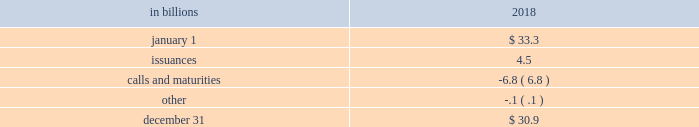The pnc financial services group , inc .
2013 form 10-k 65 liquidity and capital management liquidity risk has two fundamental components .
The first is potential loss assuming we were unable to meet our funding requirements at a reasonable cost .
The second is the potential inability to operate our businesses because adequate contingent liquidity is not available .
We manage liquidity risk at the consolidated company level ( bank , parent company and nonbank subsidiaries combined ) to help ensure that we can obtain cost-effective funding to meet current and future obligations under both normal 201cbusiness as usual 201d and stressful circumstances , and to help ensure that we maintain an appropriate level of contingent liquidity .
Management monitors liquidity through a series of early warning indicators that may indicate a potential market , or pnc-specific , liquidity stress event .
In addition , management performs a set of liquidity stress tests over multiple time horizons with varying levels of severity and maintains a contingency funding plan to address a potential liquidity stress event .
In the most severe liquidity stress simulation , we assume that our liquidity position is under pressure , while the market in general is under systemic pressure .
The simulation considers , among other things , the impact of restricted access to both secured and unsecured external sources of funding , accelerated run-off of customer deposits , valuation pressure on assets and heavy demand to fund committed obligations .
Parent company liquidity guidelines are designed to help ensure that sufficient liquidity is available to meet our parent company obligations over the succeeding 24-month period .
Liquidity-related risk limits are established within our enterprise liquidity management policy and supporting policies .
Management committees , including the asset and liability committee , and the board of directors and its risk committee regularly review compliance with key established limits .
In addition to these liquidity monitoring measures and tools described above , we also monitor our liquidity by reference to the liquidity coverage ratio ( lcr ) which is further described in the supervision and regulation section in item 1 of this report .
Pnc and pnc bank calculate the lcr on a daily basis and as of december 31 , 2018 , the lcr for pnc and pnc bank exceeded the fully phased-in requirement of 100% ( 100 % ) .
We provide additional information regarding regulatory liquidity requirements and their potential impact on us in the supervision and regulation section of item 1 business and item 1a risk factors of this report .
Sources of liquidity our largest source of liquidity on a consolidated basis is the customer deposit base generated by our banking businesses .
These deposits provide relatively stable and low-cost funding .
Total deposits increased to $ 267.8 billion at december 31 , 2018 from $ 265.1 billion at december 31 , 2017 driven by growth in interest-bearing deposits partially offset by a decrease in noninterest-bearing deposits .
See the funding sources section of the consolidated balance sheet review in this report for additional information related to our deposits .
Additionally , certain assets determined by us to be liquid as well as unused borrowing capacity from a number of sources are also available to manage our liquidity position .
At december 31 , 2018 , our liquid assets consisted of short-term investments ( federal funds sold , resale agreements , trading securities and interest-earning deposits with banks ) totaling $ 22.1 billion and securities available for sale totaling $ 63.4 billion .
The level of liquid assets fluctuates over time based on many factors , including market conditions , loan and deposit growth and balance sheet management activities .
Our liquid assets included $ 2.7 billion of securities available for sale and trading securities pledged as collateral to secure public and trust deposits , repurchase agreements and for other purposes .
In addition , $ 4.9 billion of securities held to maturity were also pledged as collateral for these purposes .
We also obtain liquidity through various forms of funding , including long-term debt ( senior notes , subordinated debt and fhlb borrowings ) and short-term borrowings ( securities sold under repurchase agreements , commercial paper and other short-term borrowings ) .
See note 10 borrowed funds and the funding sources section of the consolidated balance sheet review in this report for additional information related to our borrowings .
Total senior and subordinated debt , on a consolidated basis , decreased due to the following activity : table 24 : senior and subordinated debt .

At december 31 , 2018what was the liquid assets consisted made of short-term investments? 
Computations: (22.1 / (22.1 + 63.4))
Answer: 0.25848. The pnc financial services group , inc .
2013 form 10-k 65 liquidity and capital management liquidity risk has two fundamental components .
The first is potential loss assuming we were unable to meet our funding requirements at a reasonable cost .
The second is the potential inability to operate our businesses because adequate contingent liquidity is not available .
We manage liquidity risk at the consolidated company level ( bank , parent company and nonbank subsidiaries combined ) to help ensure that we can obtain cost-effective funding to meet current and future obligations under both normal 201cbusiness as usual 201d and stressful circumstances , and to help ensure that we maintain an appropriate level of contingent liquidity .
Management monitors liquidity through a series of early warning indicators that may indicate a potential market , or pnc-specific , liquidity stress event .
In addition , management performs a set of liquidity stress tests over multiple time horizons with varying levels of severity and maintains a contingency funding plan to address a potential liquidity stress event .
In the most severe liquidity stress simulation , we assume that our liquidity position is under pressure , while the market in general is under systemic pressure .
The simulation considers , among other things , the impact of restricted access to both secured and unsecured external sources of funding , accelerated run-off of customer deposits , valuation pressure on assets and heavy demand to fund committed obligations .
Parent company liquidity guidelines are designed to help ensure that sufficient liquidity is available to meet our parent company obligations over the succeeding 24-month period .
Liquidity-related risk limits are established within our enterprise liquidity management policy and supporting policies .
Management committees , including the asset and liability committee , and the board of directors and its risk committee regularly review compliance with key established limits .
In addition to these liquidity monitoring measures and tools described above , we also monitor our liquidity by reference to the liquidity coverage ratio ( lcr ) which is further described in the supervision and regulation section in item 1 of this report .
Pnc and pnc bank calculate the lcr on a daily basis and as of december 31 , 2018 , the lcr for pnc and pnc bank exceeded the fully phased-in requirement of 100% ( 100 % ) .
We provide additional information regarding regulatory liquidity requirements and their potential impact on us in the supervision and regulation section of item 1 business and item 1a risk factors of this report .
Sources of liquidity our largest source of liquidity on a consolidated basis is the customer deposit base generated by our banking businesses .
These deposits provide relatively stable and low-cost funding .
Total deposits increased to $ 267.8 billion at december 31 , 2018 from $ 265.1 billion at december 31 , 2017 driven by growth in interest-bearing deposits partially offset by a decrease in noninterest-bearing deposits .
See the funding sources section of the consolidated balance sheet review in this report for additional information related to our deposits .
Additionally , certain assets determined by us to be liquid as well as unused borrowing capacity from a number of sources are also available to manage our liquidity position .
At december 31 , 2018 , our liquid assets consisted of short-term investments ( federal funds sold , resale agreements , trading securities and interest-earning deposits with banks ) totaling $ 22.1 billion and securities available for sale totaling $ 63.4 billion .
The level of liquid assets fluctuates over time based on many factors , including market conditions , loan and deposit growth and balance sheet management activities .
Our liquid assets included $ 2.7 billion of securities available for sale and trading securities pledged as collateral to secure public and trust deposits , repurchase agreements and for other purposes .
In addition , $ 4.9 billion of securities held to maturity were also pledged as collateral for these purposes .
We also obtain liquidity through various forms of funding , including long-term debt ( senior notes , subordinated debt and fhlb borrowings ) and short-term borrowings ( securities sold under repurchase agreements , commercial paper and other short-term borrowings ) .
See note 10 borrowed funds and the funding sources section of the consolidated balance sheet review in this report for additional information related to our borrowings .
Total senior and subordinated debt , on a consolidated basis , decreased due to the following activity : table 24 : senior and subordinated debt .

At december 31 , 2018 , were securities available for sale greater than total senior and subordinated debt? 
Computations: (63.4 > 30.9)
Answer: yes. 